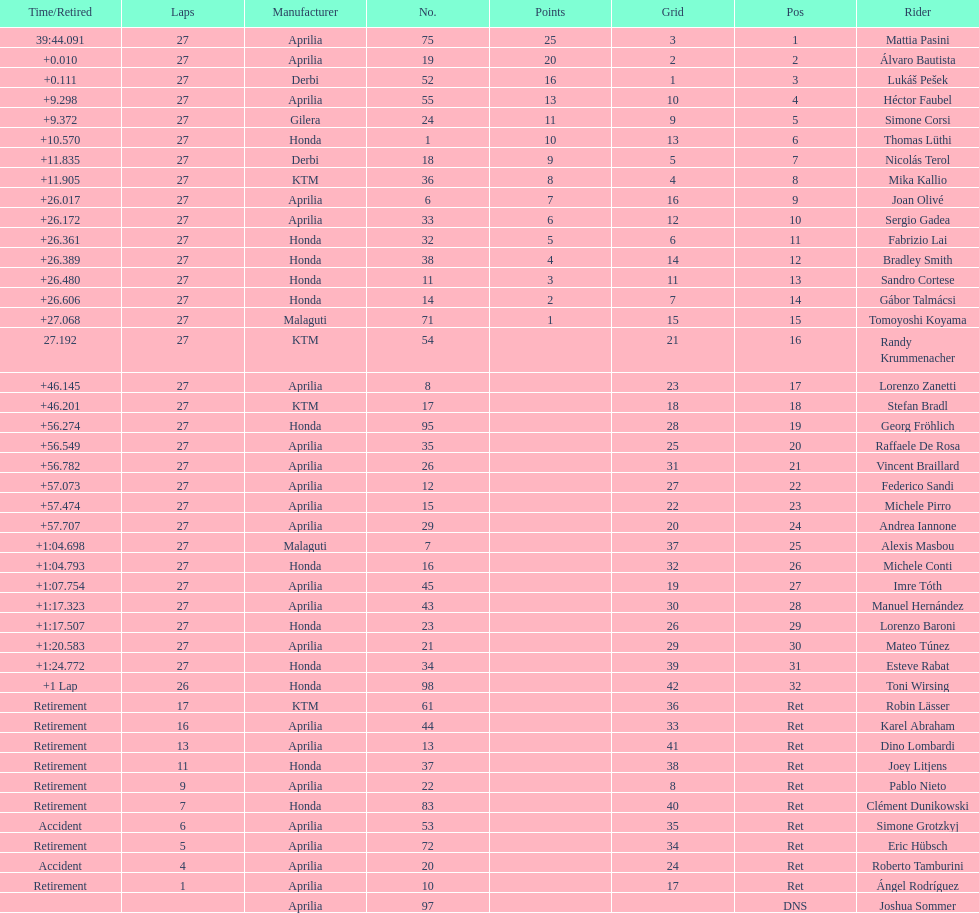Name a racer that had at least 20 points. Mattia Pasini. 